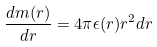Convert formula to latex. <formula><loc_0><loc_0><loc_500><loc_500>\frac { d m ( r ) } { d r } = 4 \pi \epsilon ( r ) r ^ { 2 } d r</formula> 